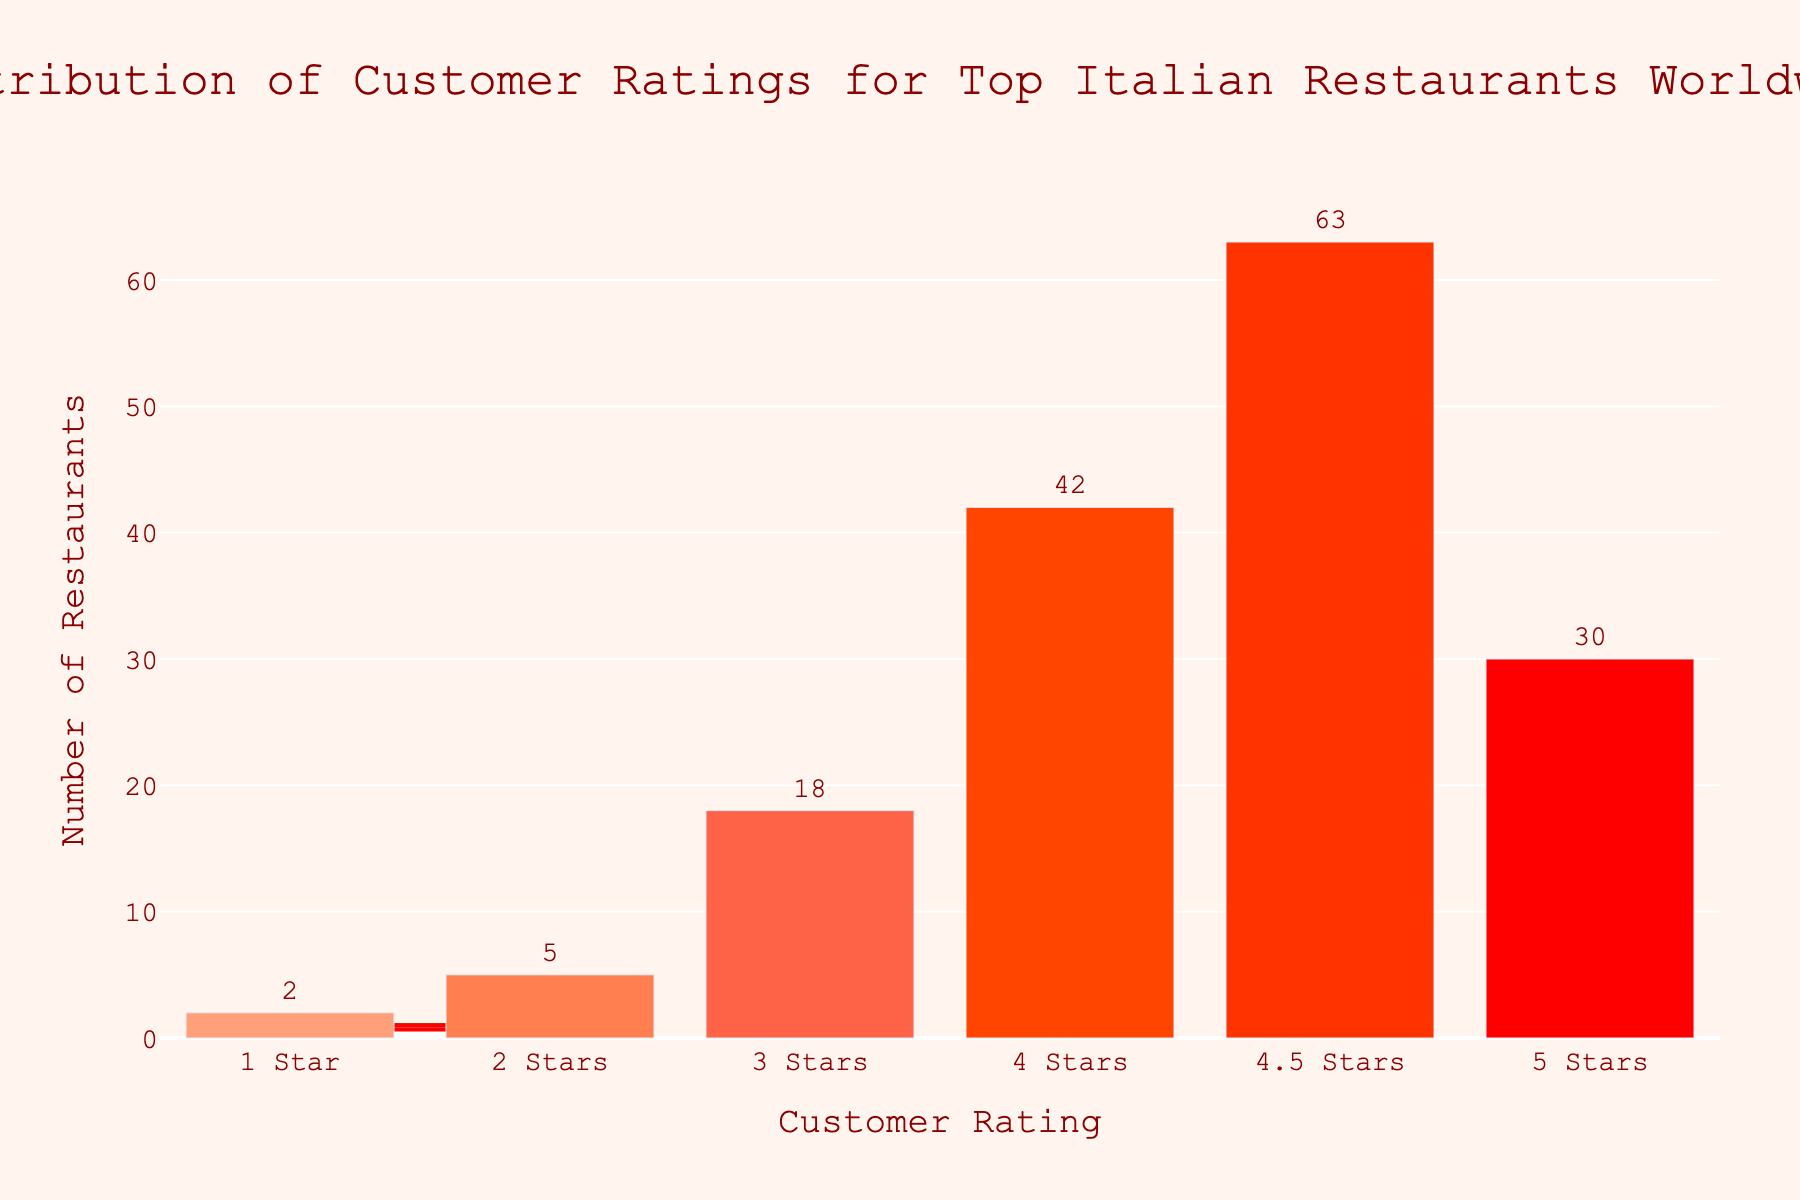What's the title of the figure? The title is written at the top center of the figure. It summarizes the content of the figure.
Answer: Distribution of Customer Ratings for Top Italian Restaurants Worldwide What is the x-axis representing? The x-axis title is "Customer Rating", which indicates that the x-axis shows the different ratings given to the restaurants.
Answer: Customer Rating What rating has the highest number of restaurants? The bar for the 4.5 Stars rating is the highest among all bars in the figure, indicating it has the most restaurants.
Answer: 4.5 Stars How many restaurants have a 3-star rating? The text label above the bar for the 3 Stars rating indicates the number of restaurants.
Answer: 18 By how many does the number of restaurants with 4 stars exceed those with 5 stars? The count for 4 stars is 42, and for 5 stars is 30. The difference is calculated by subtracting the smaller number from the larger number: 42 - 30.
Answer: 12 How many more restaurants have 4.5 stars compared to 3 stars? The count for 4.5 stars is 63, and for 3 stars is 18. Subtracting these gives 63 - 18.
Answer: 45 What's the total number of restaurants depicted in the figure? Sum up all the numbers from each rating category: 2 + 5 + 18 + 42 + 63 + 30 = 160.
Answer: 160 Which ratings have less than 10 restaurants? Check each rating's count and see which ones are less than 10: 1 Star (2) and 2 Stars (5) both have less than 10.
Answer: 1 Star, 2 Stars What percentage of restaurants have a 4.5-star rating? The count for 4.5 stars is 63. Divide this by the total number of restaurants and multiply by 100 to get the percentage: (63 / 160) * 100 ≈ 39.38%.
Answer: ~39.38% 